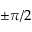Convert formula to latex. <formula><loc_0><loc_0><loc_500><loc_500>\pm \pi / 2</formula> 